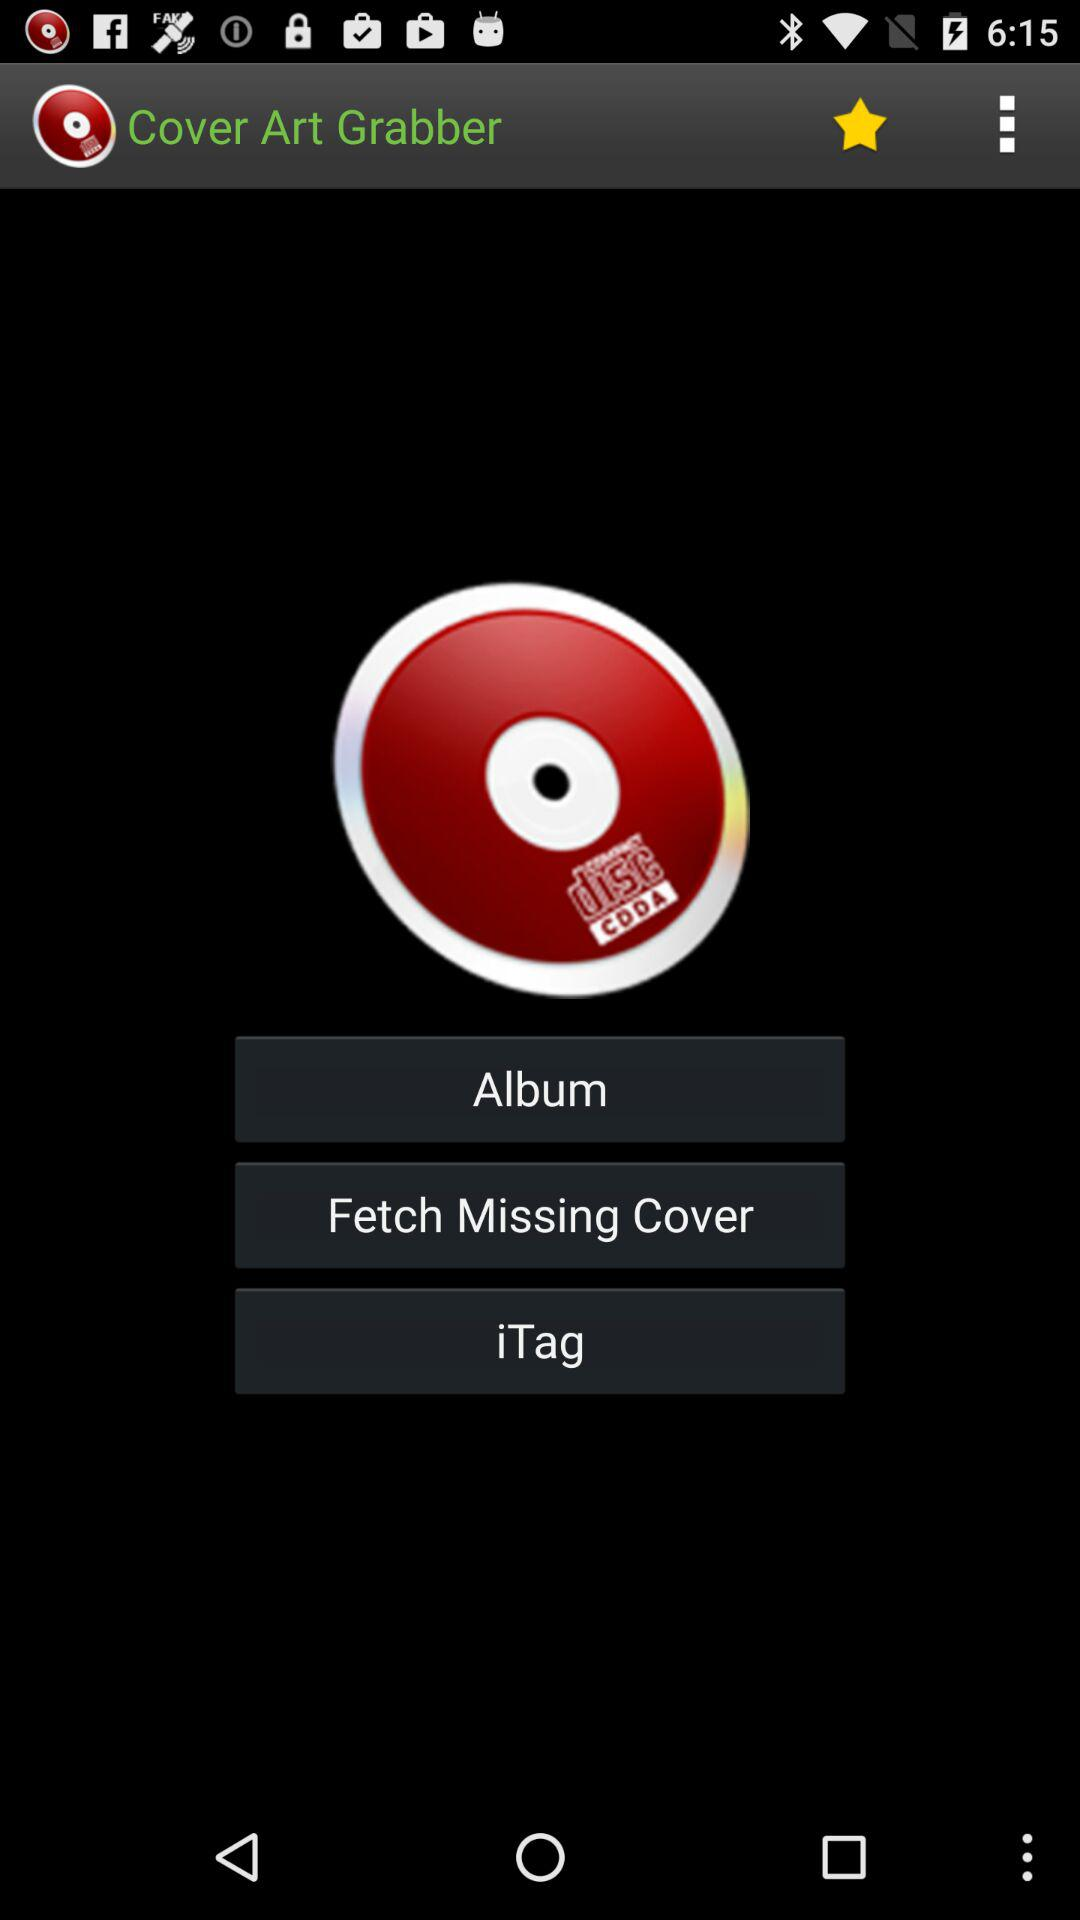What is the application name? The application name is "Cover Art Grabber". 